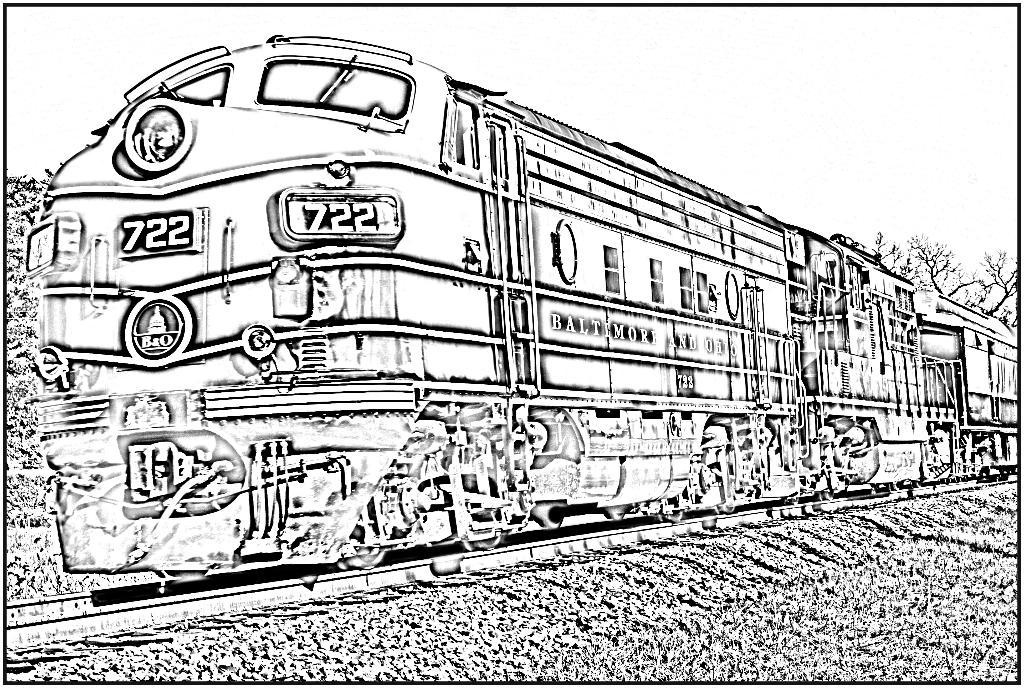What is the main subject of the sketch in the image? The main subject of the sketch in the image is the sky. What other elements are included in the sketch? The sketch includes trees, the ground, a train, and a railway track. What type of cream is being used to create the humor in the sketch? There is no cream or humor present in the sketch; it is a simple drawing of the sky, trees, the ground, a train, and a railway track. 